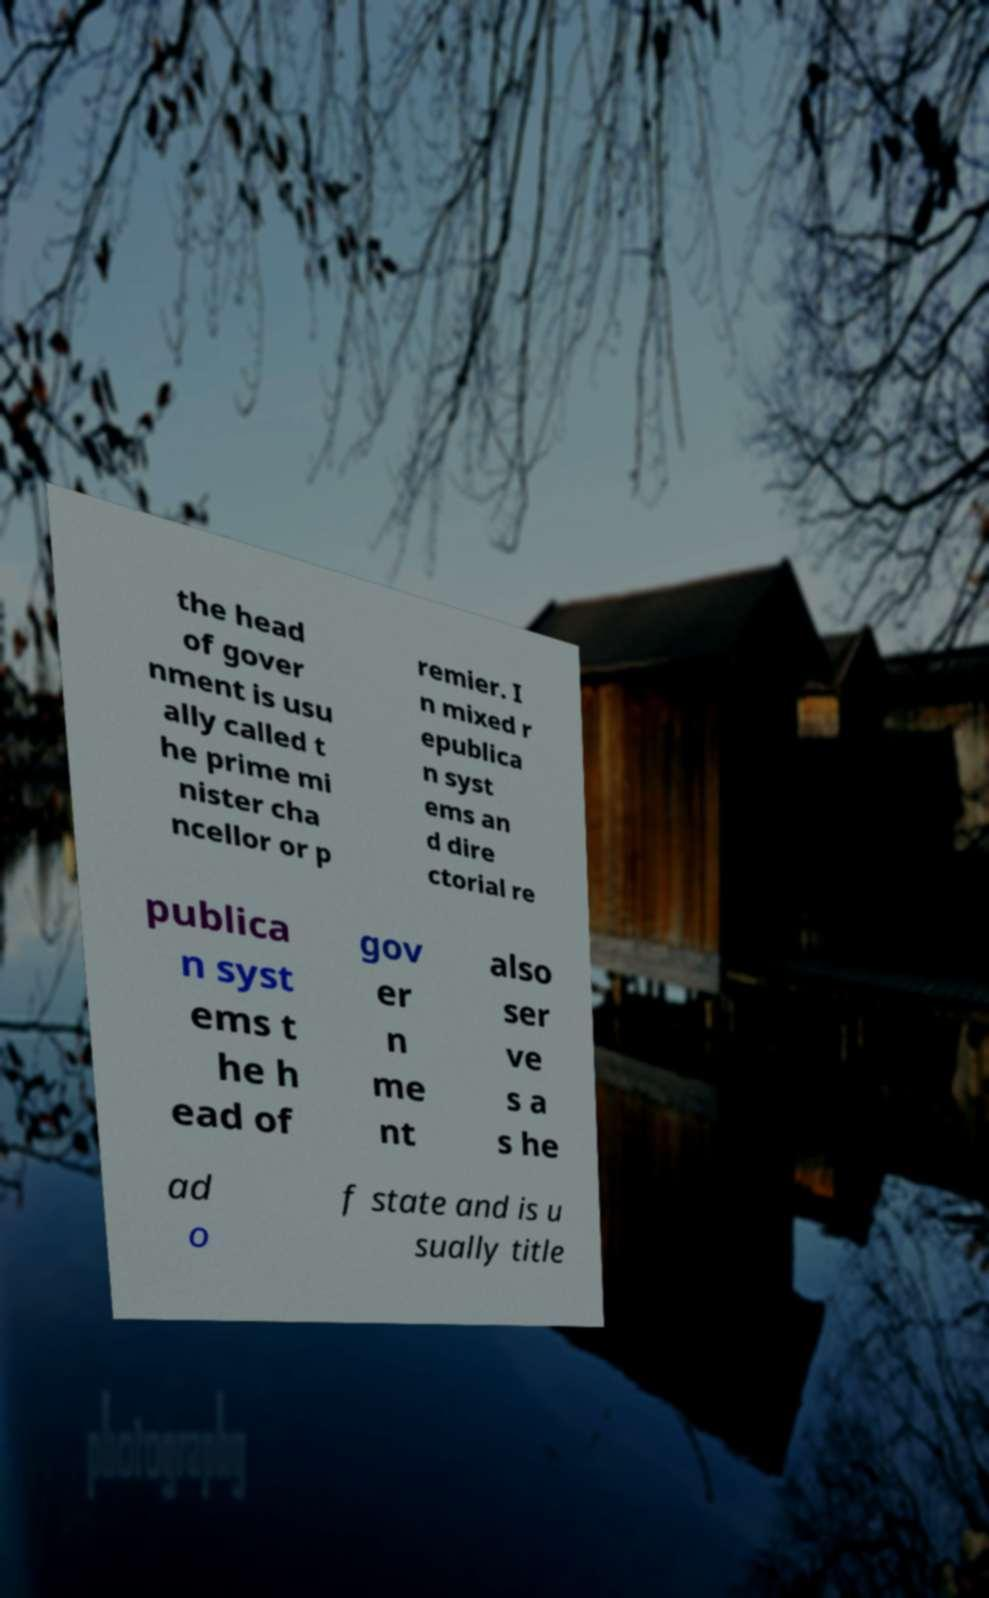Can you read and provide the text displayed in the image?This photo seems to have some interesting text. Can you extract and type it out for me? the head of gover nment is usu ally called t he prime mi nister cha ncellor or p remier. I n mixed r epublica n syst ems an d dire ctorial re publica n syst ems t he h ead of gov er n me nt also ser ve s a s he ad o f state and is u sually title 